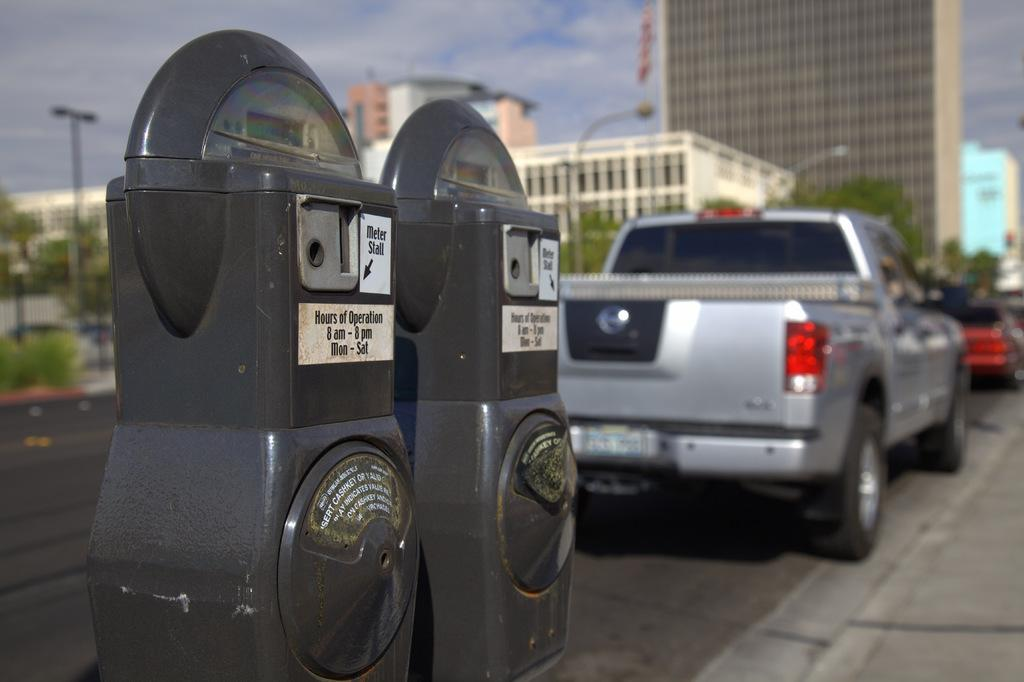<image>
Present a compact description of the photo's key features. The posted hours for the meters by the truck are from 8 am to 8 pm. 